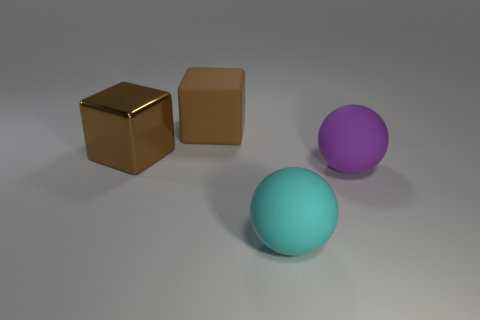Are there any tiny blue cubes that have the same material as the cyan sphere?
Provide a succinct answer. No. There is a cyan sphere that is the same size as the purple matte ball; what material is it?
Ensure brevity in your answer.  Rubber. There is a cube to the left of the big brown block that is behind the big brown object that is in front of the brown rubber block; what is its color?
Your response must be concise. Brown. There is a matte thing that is on the left side of the large cyan matte ball; is its shape the same as the thing in front of the purple matte object?
Your answer should be compact. No. What number of tiny purple metallic balls are there?
Ensure brevity in your answer.  0. The metal thing that is the same size as the cyan matte sphere is what color?
Provide a short and direct response. Brown. Do the ball in front of the purple rubber object and the cube right of the brown metallic object have the same material?
Keep it short and to the point. Yes. How big is the matte sphere in front of the big purple rubber sphere that is in front of the big brown shiny cube?
Your answer should be very brief. Large. There is a block that is behind the large metal cube; what is it made of?
Make the answer very short. Rubber. How many things are big brown things on the left side of the big brown rubber block or matte things behind the cyan rubber object?
Provide a short and direct response. 3. 